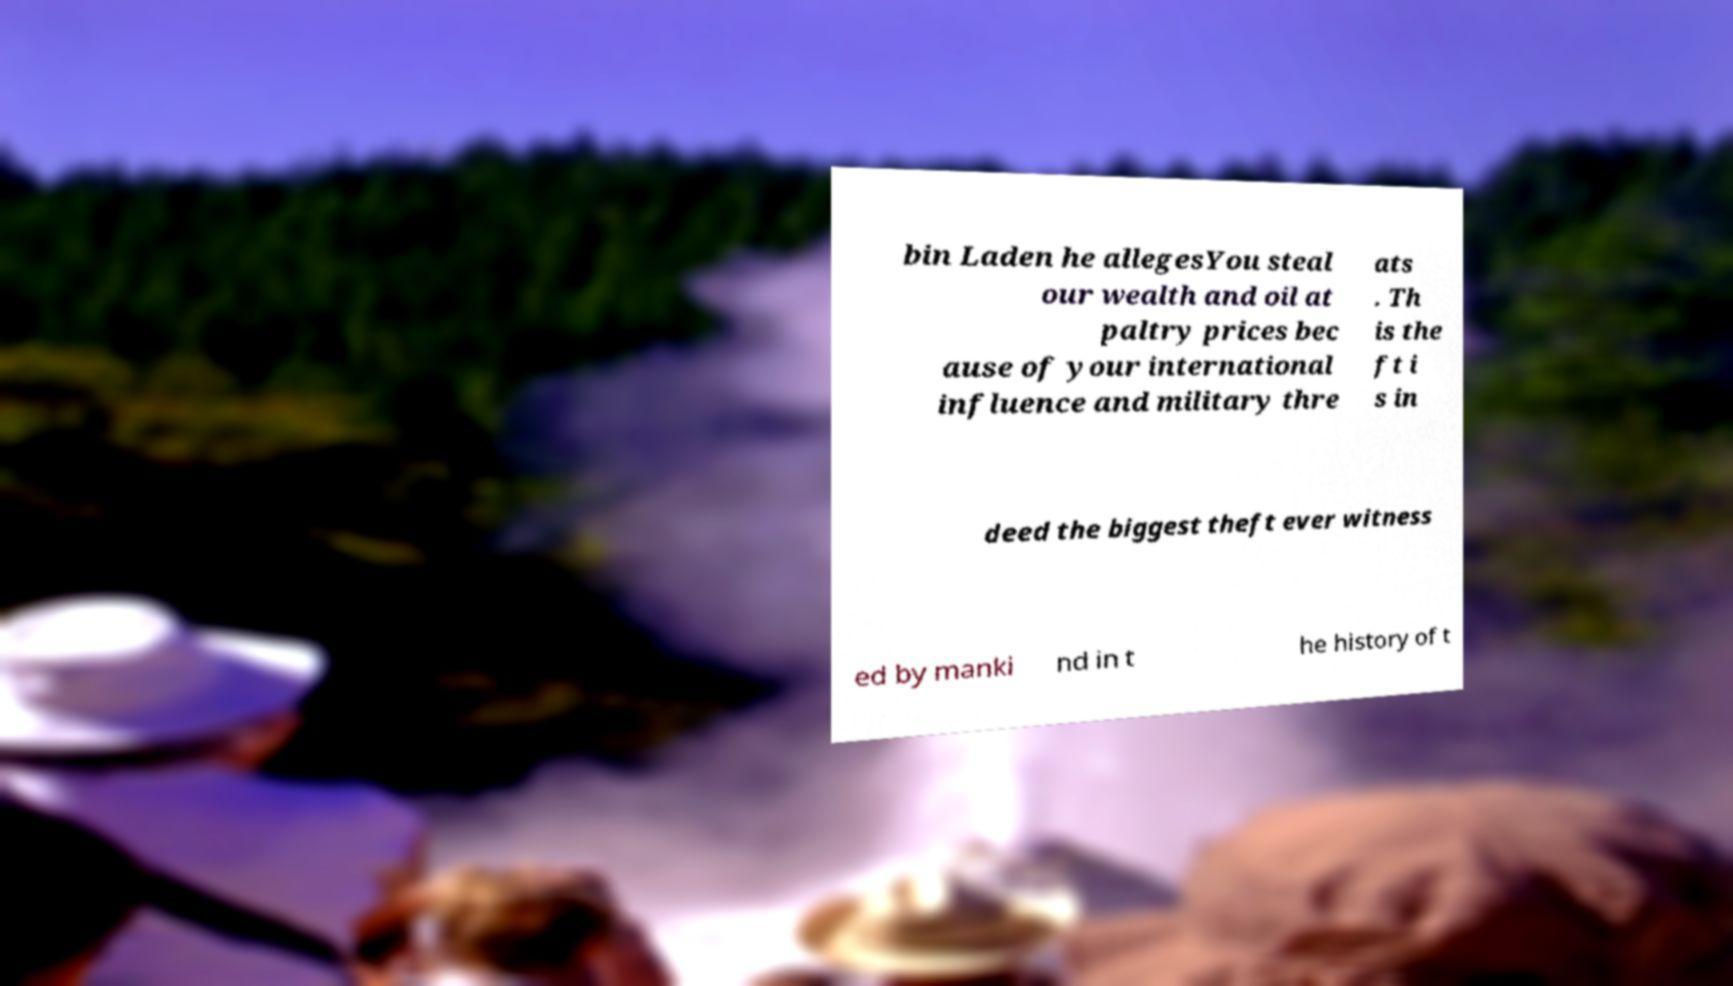There's text embedded in this image that I need extracted. Can you transcribe it verbatim? bin Laden he allegesYou steal our wealth and oil at paltry prices bec ause of your international influence and military thre ats . Th is the ft i s in deed the biggest theft ever witness ed by manki nd in t he history of t 